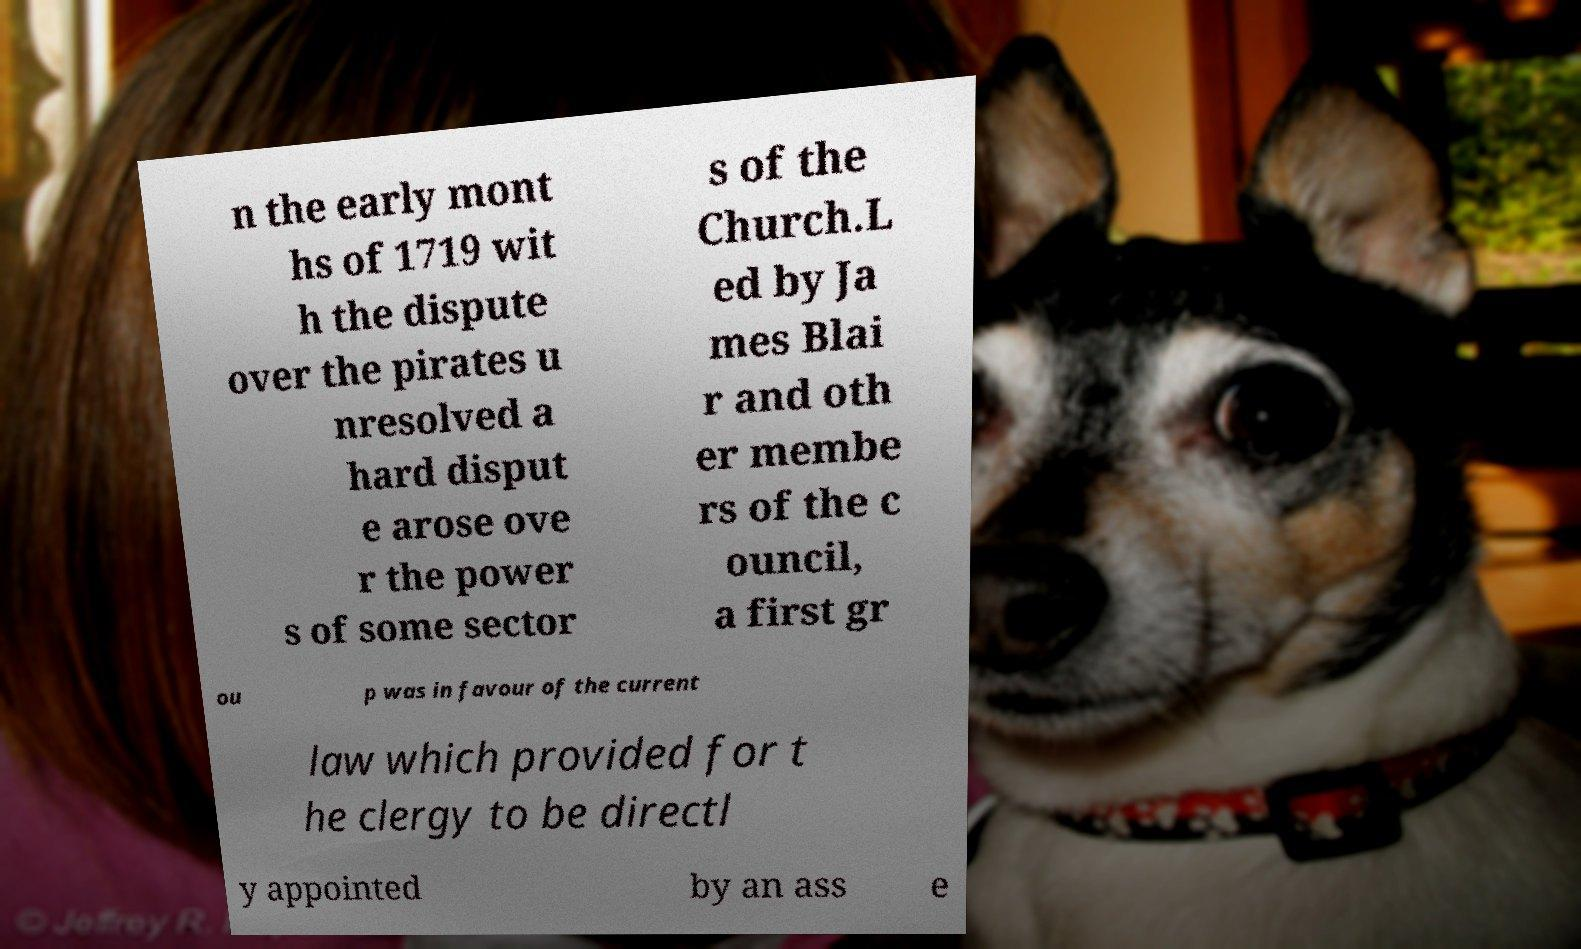Could you extract and type out the text from this image? n the early mont hs of 1719 wit h the dispute over the pirates u nresolved a hard disput e arose ove r the power s of some sector s of the Church.L ed by Ja mes Blai r and oth er membe rs of the c ouncil, a first gr ou p was in favour of the current law which provided for t he clergy to be directl y appointed by an ass e 